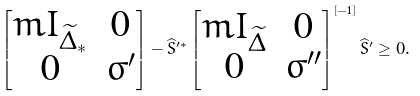<formula> <loc_0><loc_0><loc_500><loc_500>\begin{bmatrix} m I _ { \widetilde { \Delta } _ { * } } & 0 \\ 0 & \sigma ^ { \prime } \end{bmatrix} - \widehat { S } ^ { \prime * } \begin{bmatrix} m I _ { \widetilde { \Delta } } & 0 \\ 0 & \sigma ^ { \prime \prime } \end{bmatrix} ^ { [ - 1 ] } \widehat { S } ^ { \prime } \geq 0 .</formula> 